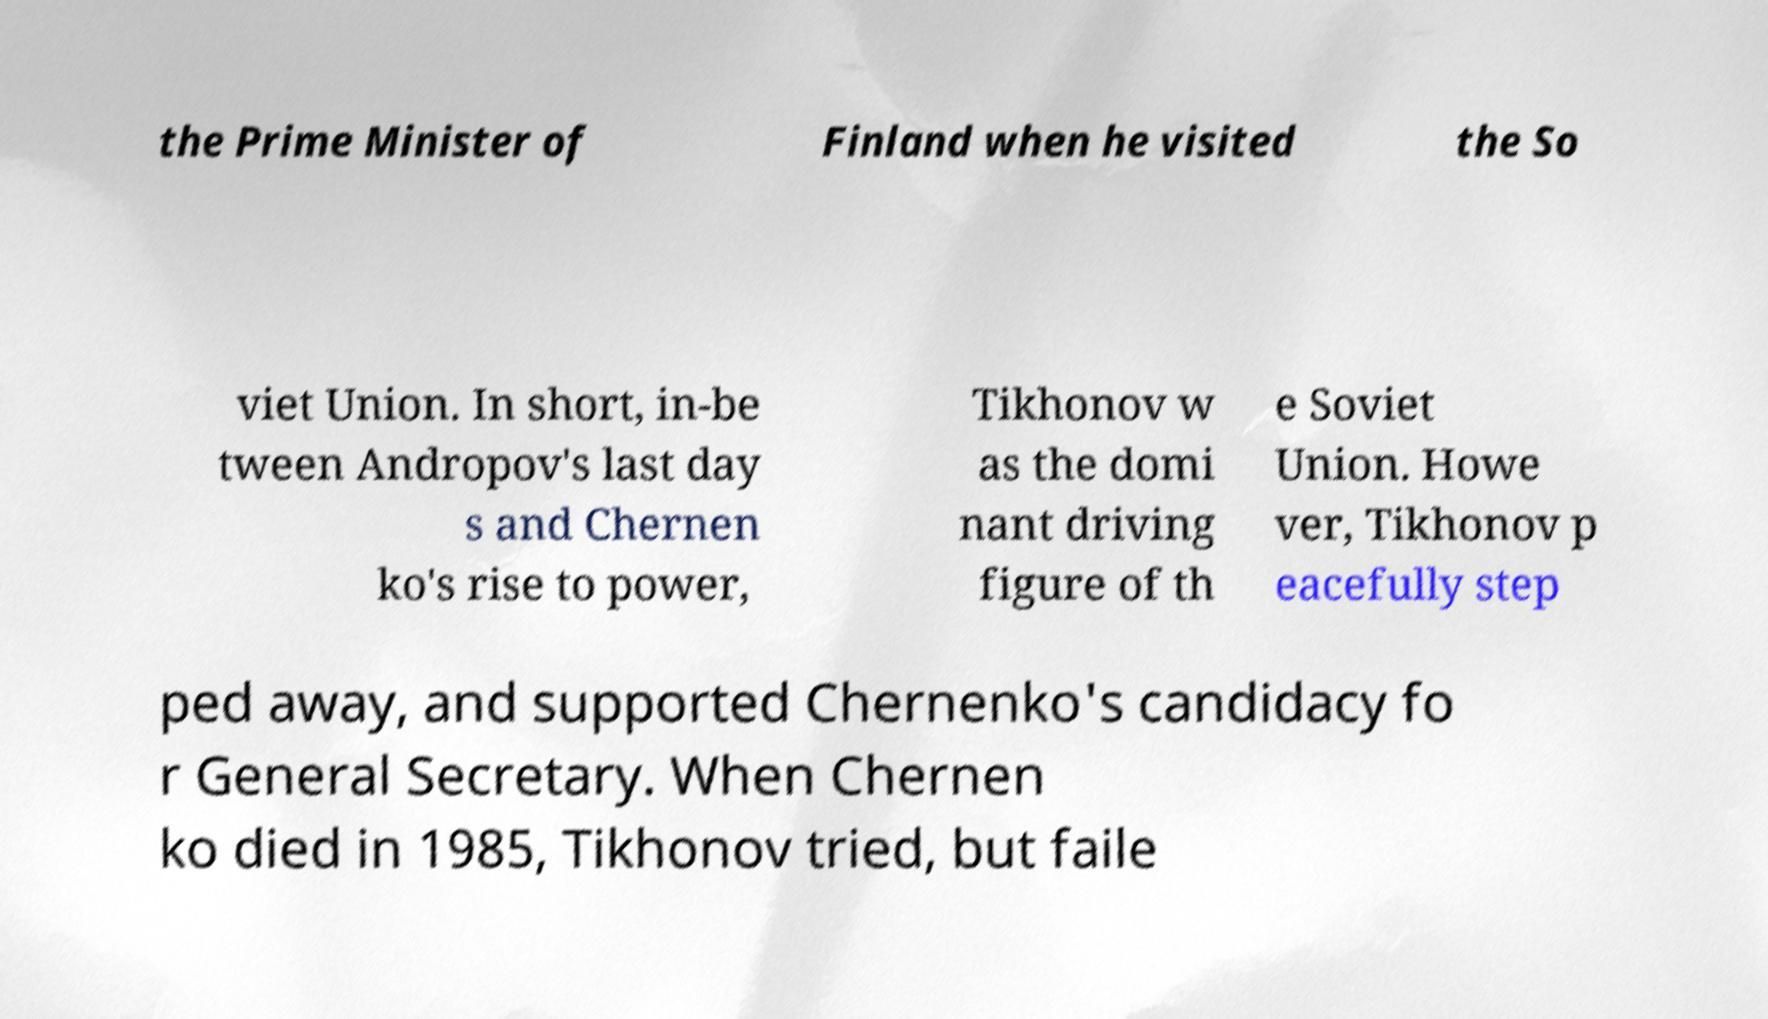Could you assist in decoding the text presented in this image and type it out clearly? the Prime Minister of Finland when he visited the So viet Union. In short, in-be tween Andropov's last day s and Chernen ko's rise to power, Tikhonov w as the domi nant driving figure of th e Soviet Union. Howe ver, Tikhonov p eacefully step ped away, and supported Chernenko's candidacy fo r General Secretary. When Chernen ko died in 1985, Tikhonov tried, but faile 